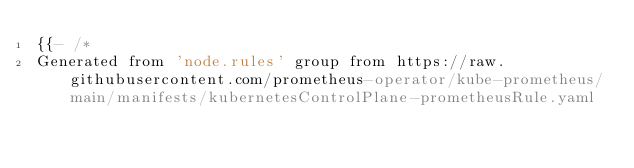<code> <loc_0><loc_0><loc_500><loc_500><_YAML_>{{- /*
Generated from 'node.rules' group from https://raw.githubusercontent.com/prometheus-operator/kube-prometheus/main/manifests/kubernetesControlPlane-prometheusRule.yaml</code> 